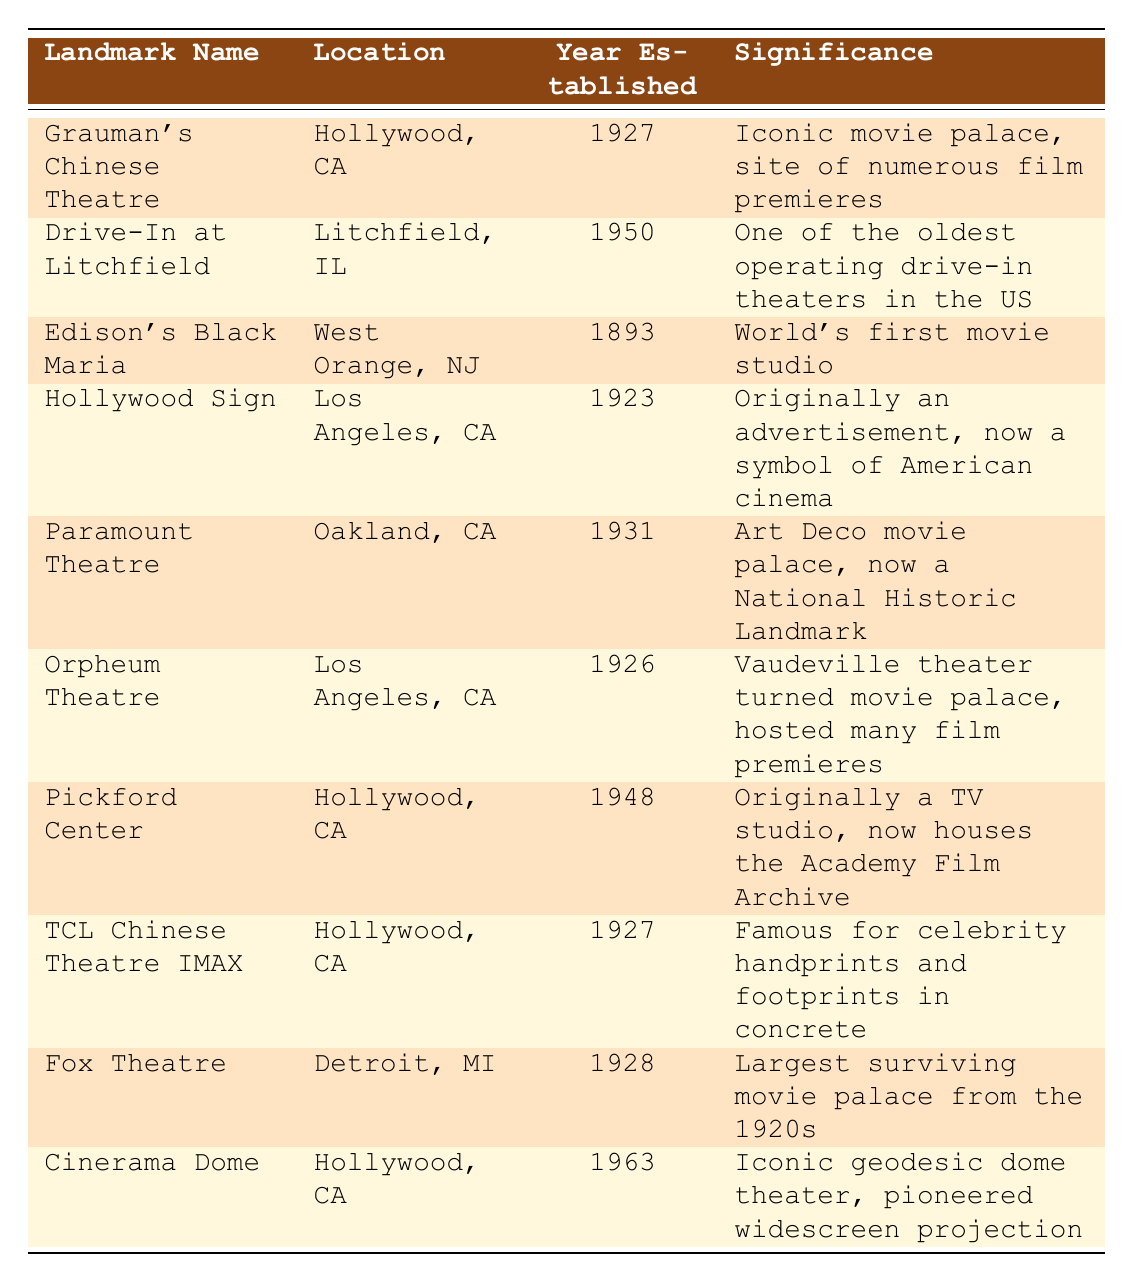What is the significance of Grauman's Chinese Theatre? The table indicates that Grauman's Chinese Theatre is an "Iconic movie palace, site of numerous film premieres."
Answer: Iconic movie palace, site of numerous film premieres In which year was Edison's Black Maria established? According to the table, Edison's Black Maria was established in "1893."
Answer: 1893 How many of the landmarks listed are located in Hollywood, CA? The table lists three landmarks located in Hollywood, CA: Grauman's Chinese Theatre, Pickford Center, and TCL Chinese Theatre IMAX.
Answer: 3 Is the Fox Theatre the largest surviving movie palace from the 1920s? Yes, the table states that the Fox Theatre is "Largest surviving movie palace from the 1920s."
Answer: Yes What year was the Drive-In at Litchfield established, and how does this compare to Edison's Black Maria? The Drive-In at Litchfield was established in 1950, while Edison's Black Maria was established in 1893. The difference in years is 1950 - 1893 = 57 years.
Answer: 1950, 57 years older than Edison's Black Maria Which landmark has an Art Deco style and is now a National Historic Landmark? According to the table, the Paramount Theatre is described as an "Art Deco movie palace, now a National Historic Landmark."
Answer: Paramount Theatre How many landmarks were established before 1930? The table lists 7 landmarks established before 1930: Edison's Black Maria (1893), Hollywood Sign (1923), Orpheum Theatre (1926), Grauman's Chinese Theatre (1927), Fox Theatre (1928), and Paramount Theatre (1931, but not included in count). Hence, the answer is 6.
Answer: 6 What can be inferred about the trend in establishing cinema landmarks based on the years? There is a notable decline in the establishment of landmarks from the 1920s (5 landmarks) to the 1960s (only 1 landmark), showing that the peak period for cinema landmark establishment was in the 1920s and begins to drop significantly thereafter.
Answer: A decline after the 1920s In what way is the Cinerama Dome significant? The table indicates that the Cinerama Dome is "Iconic geodesic dome theater, pioneered widescreen projection."
Answer: Pioneered widescreen projection 